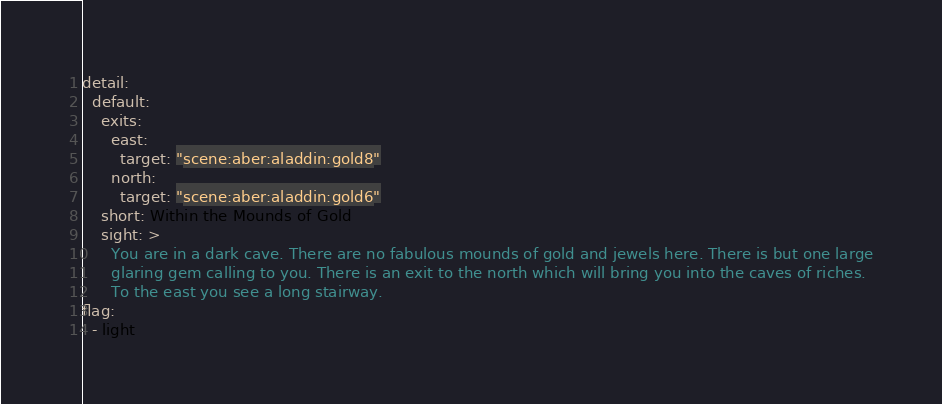<code> <loc_0><loc_0><loc_500><loc_500><_YAML_>detail:
  default:
    exits:
      east:
        target: "scene:aber:aladdin:gold8"
      north:
        target: "scene:aber:aladdin:gold6"
    short: Within the Mounds of Gold
    sight: >
      You are in a dark cave. There are no fabulous mounds of gold and jewels here. There is but one large
      glaring gem calling to you. There is an exit to the north which will bring you into the caves of riches.
      To the east you see a long stairway.
flag:
  - light
</code> 